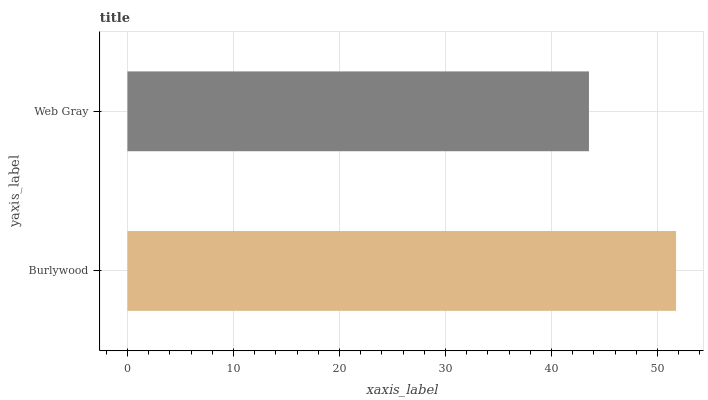Is Web Gray the minimum?
Answer yes or no. Yes. Is Burlywood the maximum?
Answer yes or no. Yes. Is Web Gray the maximum?
Answer yes or no. No. Is Burlywood greater than Web Gray?
Answer yes or no. Yes. Is Web Gray less than Burlywood?
Answer yes or no. Yes. Is Web Gray greater than Burlywood?
Answer yes or no. No. Is Burlywood less than Web Gray?
Answer yes or no. No. Is Burlywood the high median?
Answer yes or no. Yes. Is Web Gray the low median?
Answer yes or no. Yes. Is Web Gray the high median?
Answer yes or no. No. Is Burlywood the low median?
Answer yes or no. No. 